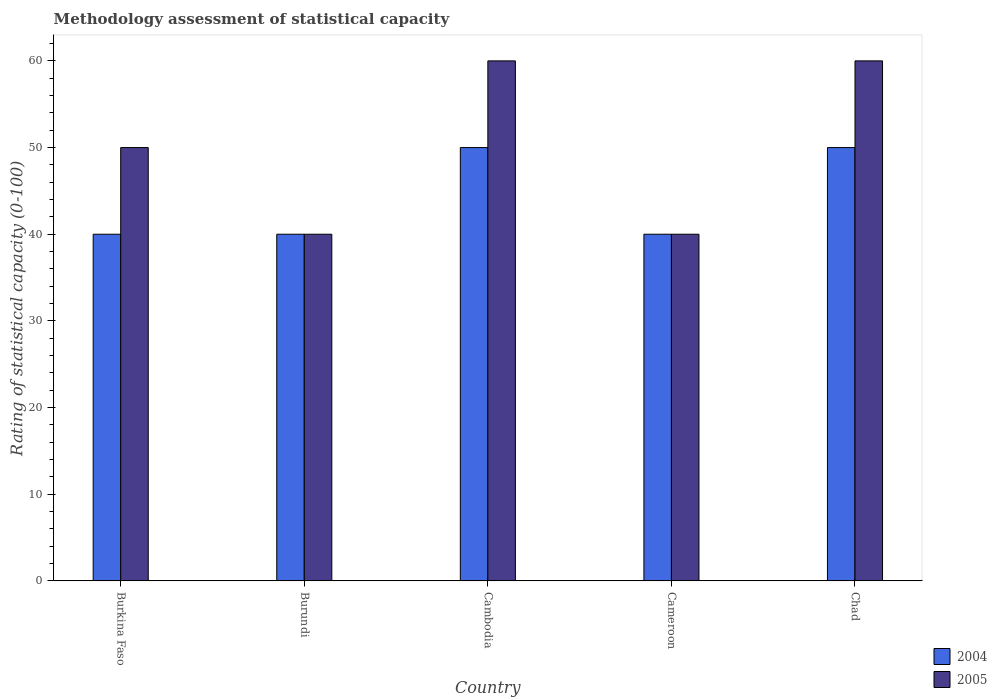Are the number of bars per tick equal to the number of legend labels?
Ensure brevity in your answer.  Yes. Are the number of bars on each tick of the X-axis equal?
Your answer should be very brief. Yes. How many bars are there on the 3rd tick from the left?
Give a very brief answer. 2. What is the label of the 3rd group of bars from the left?
Give a very brief answer. Cambodia. Across all countries, what is the minimum rating of statistical capacity in 2005?
Offer a very short reply. 40. In which country was the rating of statistical capacity in 2005 maximum?
Your answer should be compact. Cambodia. In which country was the rating of statistical capacity in 2004 minimum?
Provide a short and direct response. Burkina Faso. What is the total rating of statistical capacity in 2005 in the graph?
Your answer should be very brief. 250. What is the difference between the rating of statistical capacity in 2004 in Cambodia and that in Chad?
Offer a very short reply. 0. What is the average rating of statistical capacity in 2005 per country?
Your answer should be compact. 50. In how many countries, is the rating of statistical capacity in 2005 greater than 16?
Ensure brevity in your answer.  5. What is the ratio of the rating of statistical capacity in 2005 in Cameroon to that in Chad?
Offer a very short reply. 0.67. Is the rating of statistical capacity in 2005 in Burundi less than that in Cambodia?
Make the answer very short. Yes. What is the difference between the highest and the second highest rating of statistical capacity in 2004?
Provide a succinct answer. -10. What does the 2nd bar from the left in Cambodia represents?
Provide a short and direct response. 2005. How many countries are there in the graph?
Offer a very short reply. 5. Are the values on the major ticks of Y-axis written in scientific E-notation?
Keep it short and to the point. No. Does the graph contain any zero values?
Offer a very short reply. No. Does the graph contain grids?
Keep it short and to the point. No. How many legend labels are there?
Give a very brief answer. 2. How are the legend labels stacked?
Make the answer very short. Vertical. What is the title of the graph?
Make the answer very short. Methodology assessment of statistical capacity. Does "2013" appear as one of the legend labels in the graph?
Give a very brief answer. No. What is the label or title of the X-axis?
Offer a terse response. Country. What is the label or title of the Y-axis?
Your response must be concise. Rating of statistical capacity (0-100). What is the Rating of statistical capacity (0-100) of 2005 in Burundi?
Give a very brief answer. 40. What is the Rating of statistical capacity (0-100) of 2004 in Cambodia?
Your answer should be very brief. 50. What is the Rating of statistical capacity (0-100) of 2005 in Cambodia?
Your answer should be very brief. 60. What is the Rating of statistical capacity (0-100) of 2005 in Chad?
Ensure brevity in your answer.  60. Across all countries, what is the maximum Rating of statistical capacity (0-100) of 2005?
Give a very brief answer. 60. Across all countries, what is the minimum Rating of statistical capacity (0-100) in 2005?
Offer a very short reply. 40. What is the total Rating of statistical capacity (0-100) in 2004 in the graph?
Provide a short and direct response. 220. What is the total Rating of statistical capacity (0-100) of 2005 in the graph?
Your answer should be compact. 250. What is the difference between the Rating of statistical capacity (0-100) in 2005 in Burkina Faso and that in Burundi?
Your response must be concise. 10. What is the difference between the Rating of statistical capacity (0-100) of 2004 in Burkina Faso and that in Cambodia?
Your answer should be very brief. -10. What is the difference between the Rating of statistical capacity (0-100) in 2004 in Burkina Faso and that in Chad?
Your response must be concise. -10. What is the difference between the Rating of statistical capacity (0-100) in 2005 in Burkina Faso and that in Chad?
Ensure brevity in your answer.  -10. What is the difference between the Rating of statistical capacity (0-100) of 2005 in Burundi and that in Cambodia?
Ensure brevity in your answer.  -20. What is the difference between the Rating of statistical capacity (0-100) of 2005 in Burundi and that in Chad?
Offer a very short reply. -20. What is the difference between the Rating of statistical capacity (0-100) in 2004 in Cambodia and that in Cameroon?
Give a very brief answer. 10. What is the difference between the Rating of statistical capacity (0-100) of 2005 in Cambodia and that in Cameroon?
Your answer should be compact. 20. What is the difference between the Rating of statistical capacity (0-100) in 2004 in Cambodia and that in Chad?
Provide a short and direct response. 0. What is the difference between the Rating of statistical capacity (0-100) of 2005 in Cambodia and that in Chad?
Keep it short and to the point. 0. What is the difference between the Rating of statistical capacity (0-100) in 2004 in Cameroon and that in Chad?
Ensure brevity in your answer.  -10. What is the difference between the Rating of statistical capacity (0-100) in 2005 in Cameroon and that in Chad?
Offer a terse response. -20. What is the difference between the Rating of statistical capacity (0-100) of 2004 in Burkina Faso and the Rating of statistical capacity (0-100) of 2005 in Burundi?
Offer a very short reply. 0. What is the difference between the Rating of statistical capacity (0-100) of 2004 in Burkina Faso and the Rating of statistical capacity (0-100) of 2005 in Chad?
Make the answer very short. -20. What is the difference between the Rating of statistical capacity (0-100) of 2004 in Burundi and the Rating of statistical capacity (0-100) of 2005 in Cambodia?
Make the answer very short. -20. What is the difference between the Rating of statistical capacity (0-100) in 2004 in Burundi and the Rating of statistical capacity (0-100) in 2005 in Cameroon?
Keep it short and to the point. 0. What is the difference between the Rating of statistical capacity (0-100) of 2004 in Cambodia and the Rating of statistical capacity (0-100) of 2005 in Chad?
Offer a very short reply. -10. What is the difference between the Rating of statistical capacity (0-100) in 2004 in Cameroon and the Rating of statistical capacity (0-100) in 2005 in Chad?
Ensure brevity in your answer.  -20. What is the average Rating of statistical capacity (0-100) of 2004 per country?
Ensure brevity in your answer.  44. What is the average Rating of statistical capacity (0-100) in 2005 per country?
Your answer should be very brief. 50. What is the difference between the Rating of statistical capacity (0-100) of 2004 and Rating of statistical capacity (0-100) of 2005 in Burkina Faso?
Your answer should be compact. -10. What is the difference between the Rating of statistical capacity (0-100) of 2004 and Rating of statistical capacity (0-100) of 2005 in Cambodia?
Ensure brevity in your answer.  -10. What is the difference between the Rating of statistical capacity (0-100) of 2004 and Rating of statistical capacity (0-100) of 2005 in Cameroon?
Provide a succinct answer. 0. What is the ratio of the Rating of statistical capacity (0-100) in 2005 in Burkina Faso to that in Cameroon?
Make the answer very short. 1.25. What is the ratio of the Rating of statistical capacity (0-100) of 2005 in Burkina Faso to that in Chad?
Make the answer very short. 0.83. What is the ratio of the Rating of statistical capacity (0-100) in 2005 in Burundi to that in Cambodia?
Make the answer very short. 0.67. What is the ratio of the Rating of statistical capacity (0-100) of 2004 in Cambodia to that in Cameroon?
Provide a short and direct response. 1.25. What is the ratio of the Rating of statistical capacity (0-100) of 2005 in Cambodia to that in Cameroon?
Make the answer very short. 1.5. What is the ratio of the Rating of statistical capacity (0-100) of 2004 in Cambodia to that in Chad?
Provide a succinct answer. 1. What is the ratio of the Rating of statistical capacity (0-100) in 2004 in Cameroon to that in Chad?
Offer a very short reply. 0.8. What is the difference between the highest and the lowest Rating of statistical capacity (0-100) in 2004?
Keep it short and to the point. 10. 